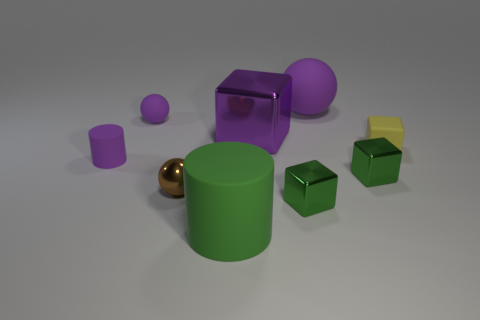Subtract all large cubes. How many cubes are left? 3 Subtract all purple blocks. How many blocks are left? 3 Subtract all blocks. How many objects are left? 5 Subtract 1 cubes. How many cubes are left? 3 Subtract all metal blocks. Subtract all purple balls. How many objects are left? 4 Add 6 large cylinders. How many large cylinders are left? 7 Add 2 rubber cylinders. How many rubber cylinders exist? 4 Add 1 purple metallic objects. How many objects exist? 10 Subtract 0 blue cylinders. How many objects are left? 9 Subtract all red blocks. Subtract all red cylinders. How many blocks are left? 4 